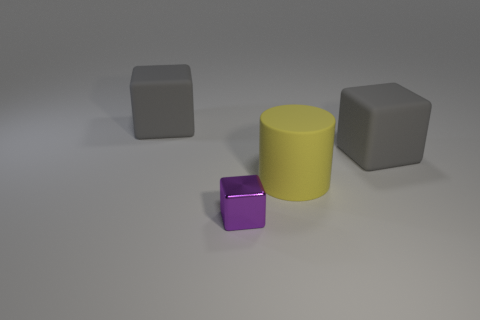Add 2 yellow cylinders. How many objects exist? 6 Subtract all cylinders. How many objects are left? 3 Subtract 0 cyan cubes. How many objects are left? 4 Subtract all cubes. Subtract all big yellow rubber things. How many objects are left? 0 Add 3 cubes. How many cubes are left? 6 Add 4 blue blocks. How many blue blocks exist? 4 